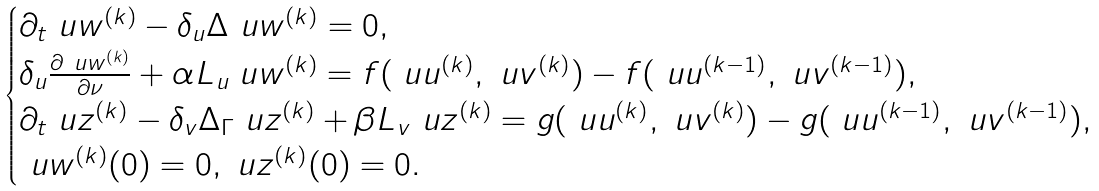<formula> <loc_0><loc_0><loc_500><loc_500>\begin{cases} \partial _ { t } \ u w ^ { ( k ) } - \delta _ { u } \Delta \ u w ^ { ( k ) } = 0 , \\ \delta _ { u } \frac { \partial \ u w ^ { ( k ) } } { \partial \nu } + \alpha L _ { u } \ u w ^ { ( k ) } = f ( \ u u ^ { ( k ) } , \ u v ^ { ( k ) } ) - f ( \ u u ^ { ( k - 1 ) } , \ u v ^ { ( k - 1 ) } ) , \\ \partial _ { t } \ u z ^ { ( k ) } - \delta _ { v } \Delta _ { \Gamma } \ u z ^ { ( k ) } + \beta L _ { v } \ u z ^ { ( k ) } = g ( \ u u ^ { ( k ) } , \ u v ^ { ( k ) } ) - g ( \ u u ^ { ( k - 1 ) } , \ u v ^ { ( k - 1 ) } ) , \\ \ u w ^ { ( k ) } ( 0 ) = 0 , \ u z ^ { ( k ) } ( 0 ) = 0 . \end{cases}</formula> 